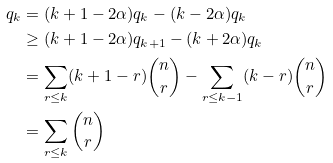Convert formula to latex. <formula><loc_0><loc_0><loc_500><loc_500>q _ { k } & = ( k + 1 - 2 \alpha ) q _ { k } - ( k - 2 \alpha ) q _ { k } \\ & \geq ( k + 1 - 2 \alpha ) q _ { k + 1 } - ( k + 2 \alpha ) q _ { k } \\ & = \sum _ { r \leq k } ( k + 1 - r ) \binom { n } { r } - \sum _ { r \leq k - 1 } ( k - r ) \binom { n } { r } \\ & = \sum _ { r \leq k } \binom { n } { r }</formula> 